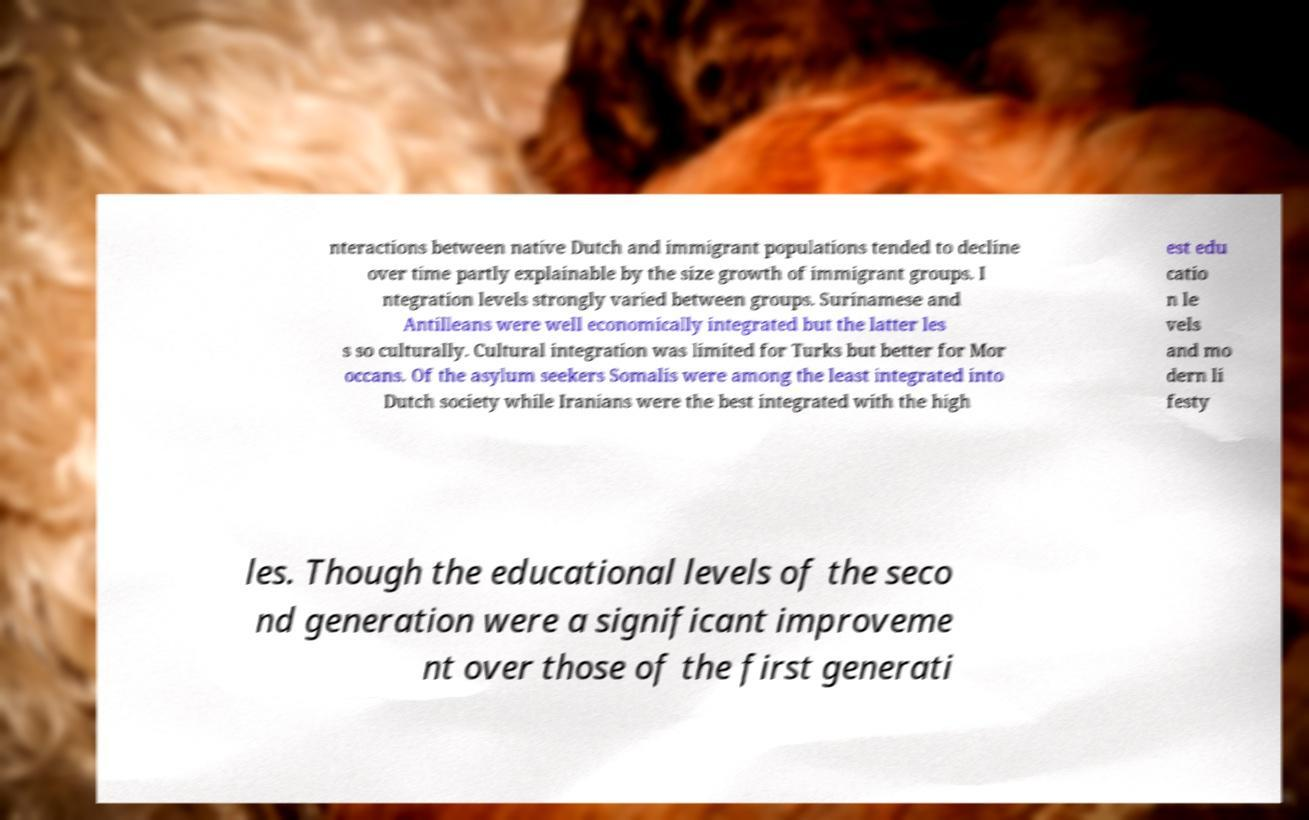Could you extract and type out the text from this image? nteractions between native Dutch and immigrant populations tended to decline over time partly explainable by the size growth of immigrant groups. I ntegration levels strongly varied between groups. Surinamese and Antilleans were well economically integrated but the latter les s so culturally. Cultural integration was limited for Turks but better for Mor occans. Of the asylum seekers Somalis were among the least integrated into Dutch society while Iranians were the best integrated with the high est edu catio n le vels and mo dern li festy les. Though the educational levels of the seco nd generation were a significant improveme nt over those of the first generati 